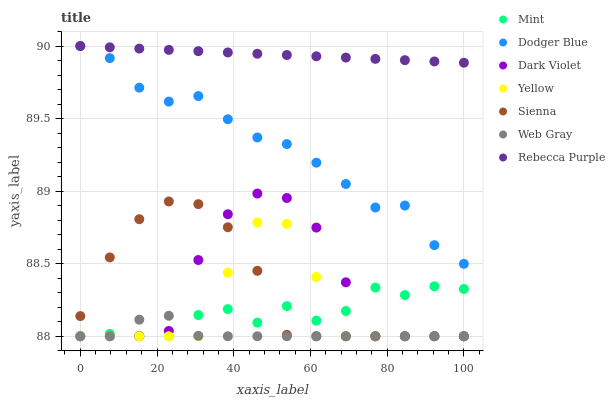Does Web Gray have the minimum area under the curve?
Answer yes or no. Yes. Does Rebecca Purple have the maximum area under the curve?
Answer yes or no. Yes. Does Yellow have the minimum area under the curve?
Answer yes or no. No. Does Yellow have the maximum area under the curve?
Answer yes or no. No. Is Rebecca Purple the smoothest?
Answer yes or no. Yes. Is Dark Violet the roughest?
Answer yes or no. Yes. Is Yellow the smoothest?
Answer yes or no. No. Is Yellow the roughest?
Answer yes or no. No. Does Web Gray have the lowest value?
Answer yes or no. Yes. Does Dodger Blue have the lowest value?
Answer yes or no. No. Does Rebecca Purple have the highest value?
Answer yes or no. Yes. Does Yellow have the highest value?
Answer yes or no. No. Is Mint less than Dodger Blue?
Answer yes or no. Yes. Is Dodger Blue greater than Web Gray?
Answer yes or no. Yes. Does Dark Violet intersect Web Gray?
Answer yes or no. Yes. Is Dark Violet less than Web Gray?
Answer yes or no. No. Is Dark Violet greater than Web Gray?
Answer yes or no. No. Does Mint intersect Dodger Blue?
Answer yes or no. No. 